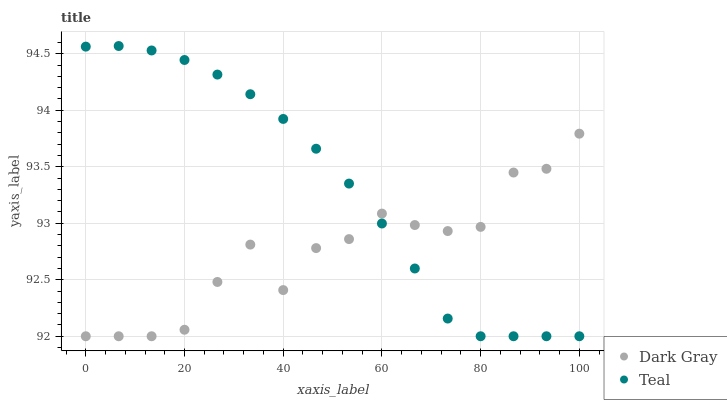Does Dark Gray have the minimum area under the curve?
Answer yes or no. Yes. Does Teal have the maximum area under the curve?
Answer yes or no. Yes. Does Teal have the minimum area under the curve?
Answer yes or no. No. Is Teal the smoothest?
Answer yes or no. Yes. Is Dark Gray the roughest?
Answer yes or no. Yes. Is Teal the roughest?
Answer yes or no. No. Does Dark Gray have the lowest value?
Answer yes or no. Yes. Does Teal have the highest value?
Answer yes or no. Yes. Does Dark Gray intersect Teal?
Answer yes or no. Yes. Is Dark Gray less than Teal?
Answer yes or no. No. Is Dark Gray greater than Teal?
Answer yes or no. No. 